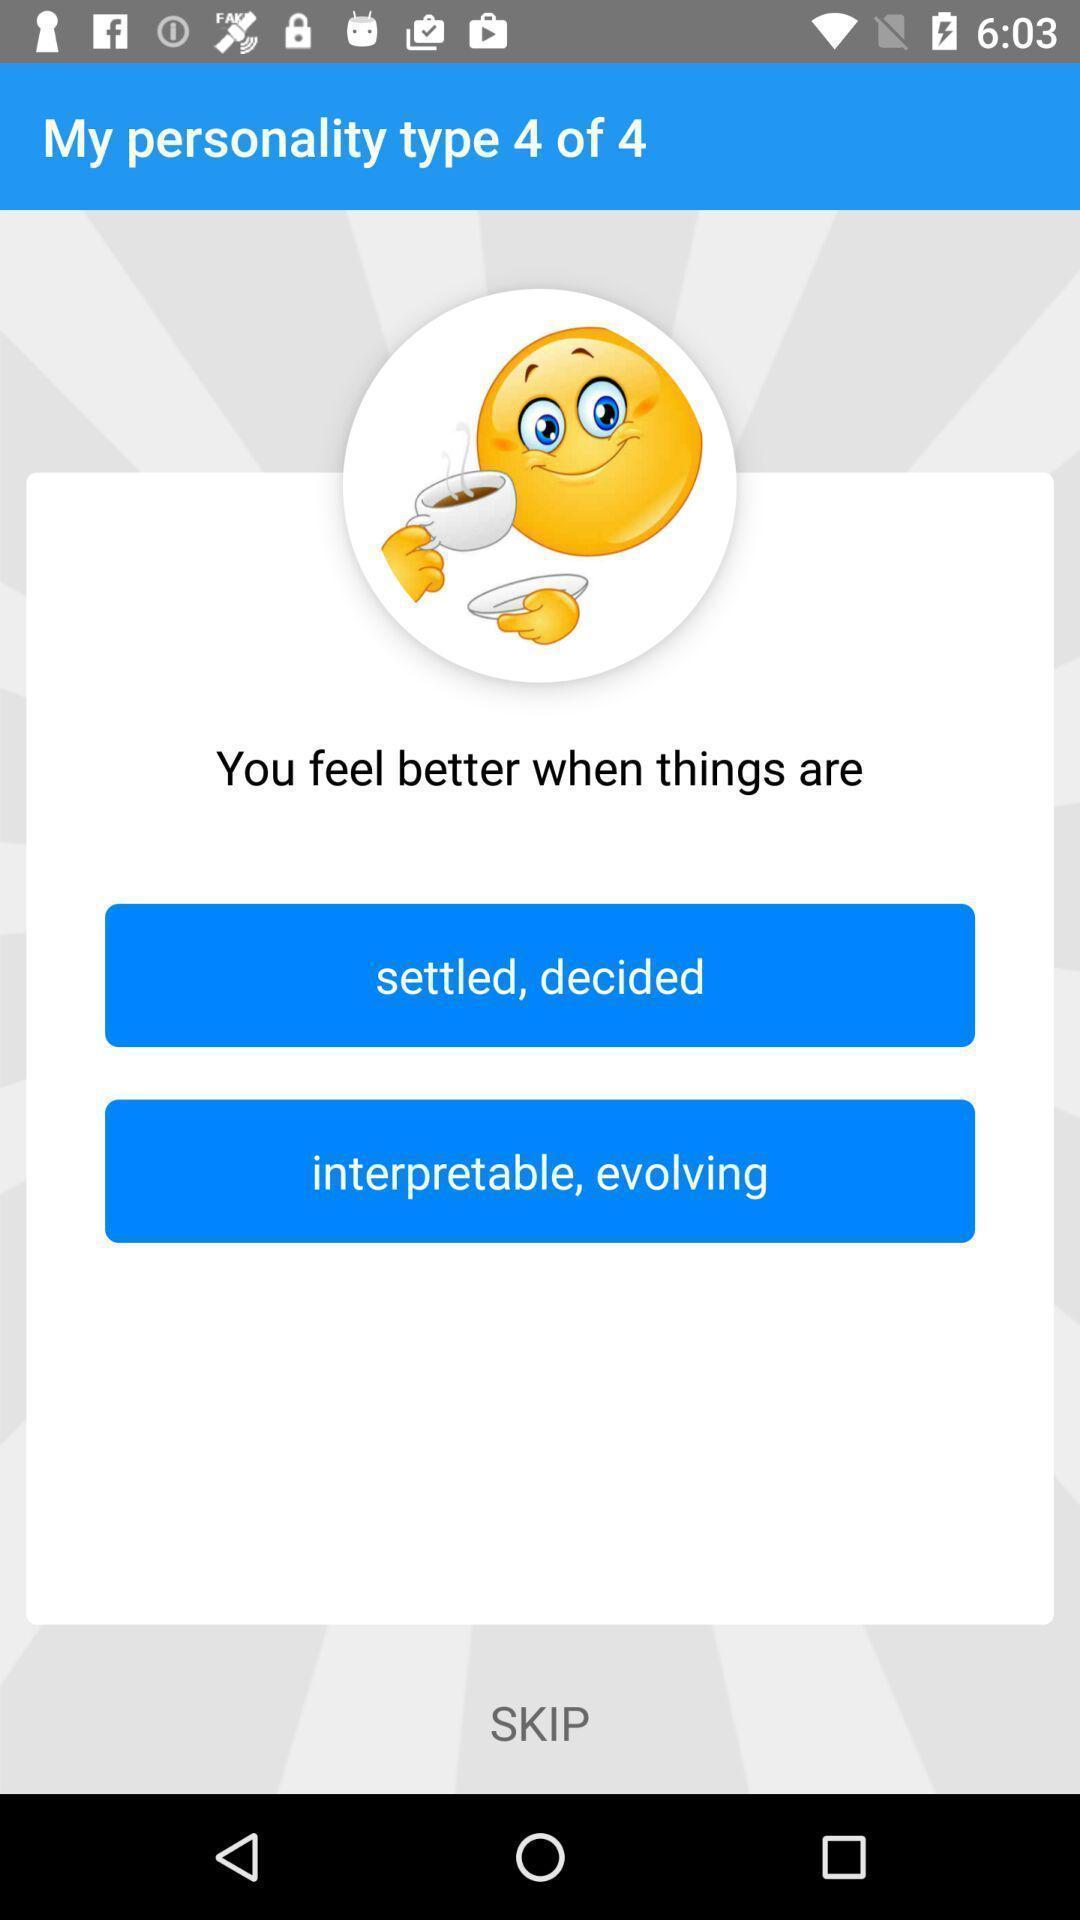Describe this image in words. Page displaying the personality development levels. 